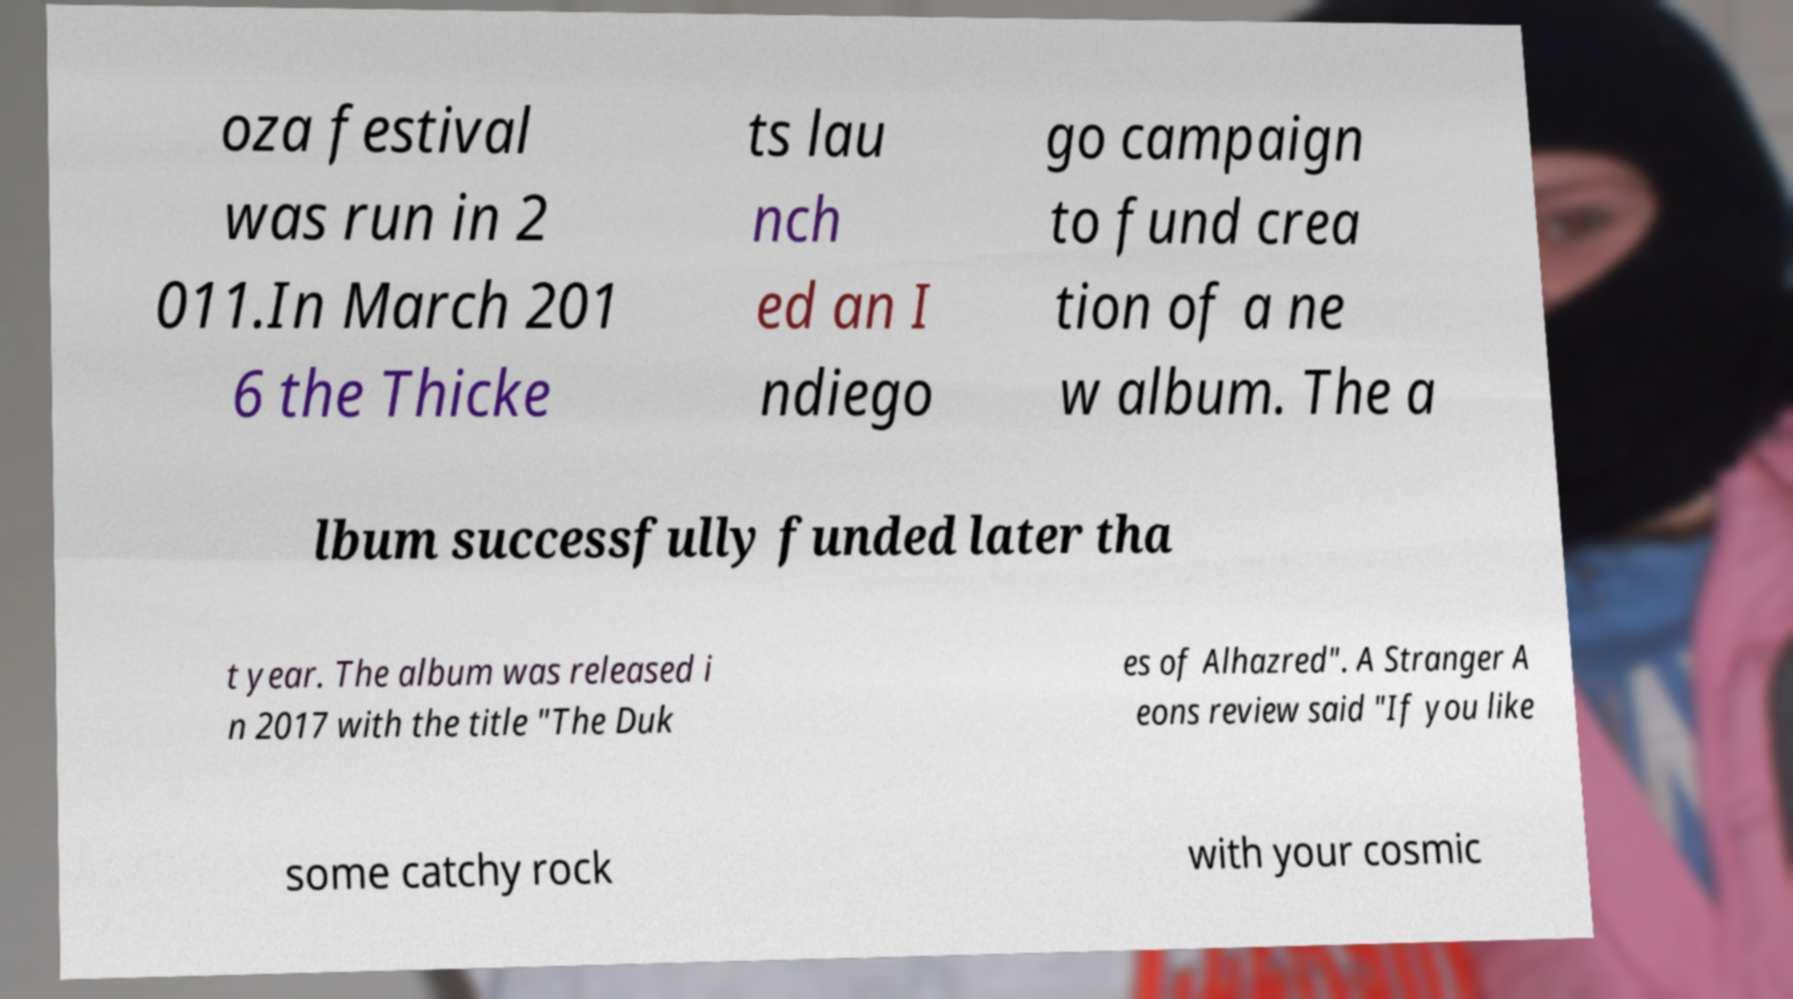Please identify and transcribe the text found in this image. oza festival was run in 2 011.In March 201 6 the Thicke ts lau nch ed an I ndiego go campaign to fund crea tion of a ne w album. The a lbum successfully funded later tha t year. The album was released i n 2017 with the title "The Duk es of Alhazred". A Stranger A eons review said "If you like some catchy rock with your cosmic 